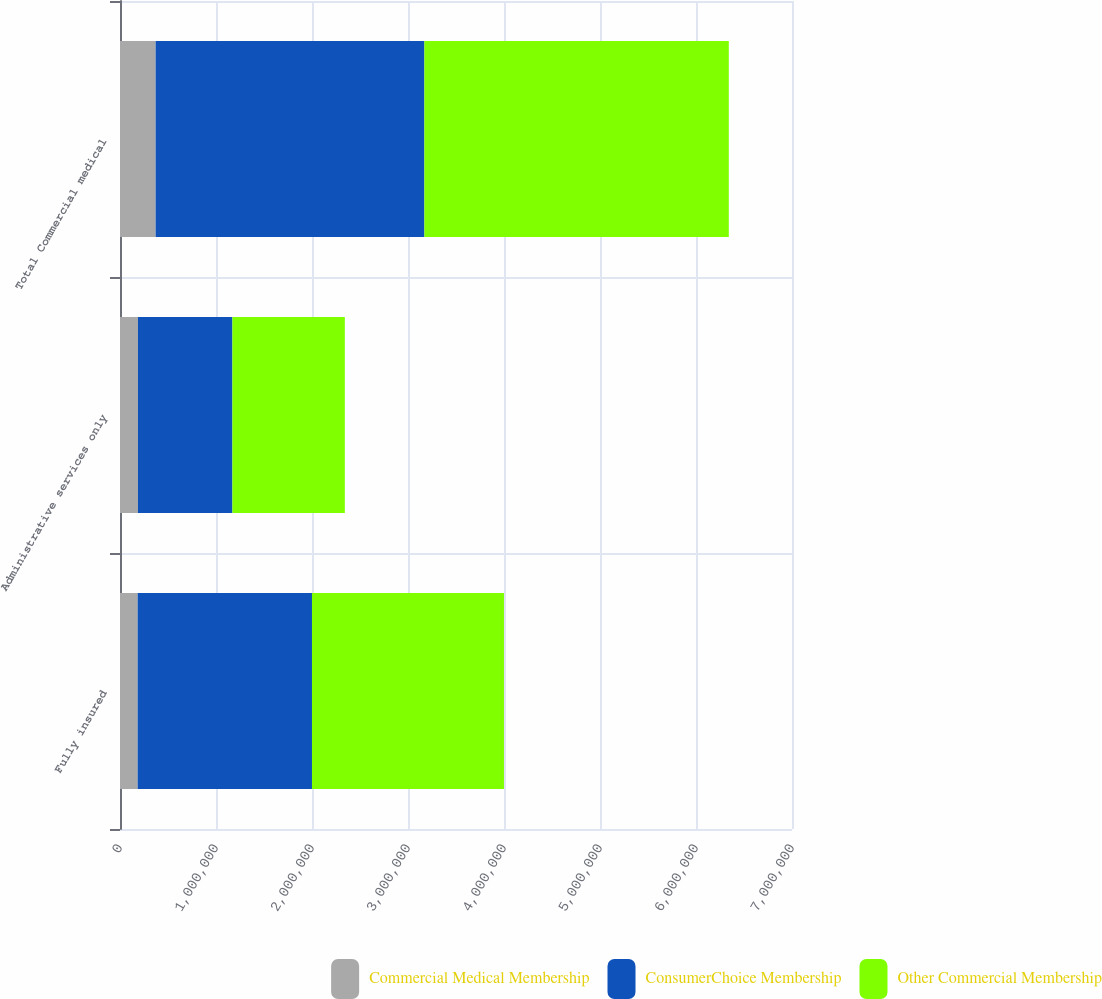Convert chart to OTSL. <chart><loc_0><loc_0><loc_500><loc_500><stacked_bar_chart><ecel><fcel>Fully insured<fcel>Administrative services only<fcel>Total Commercial medical<nl><fcel>Commercial Medical Membership<fcel>184000<fcel>187100<fcel>371100<nl><fcel>ConsumerChoice Membership<fcel>1.8158e+06<fcel>983900<fcel>2.7997e+06<nl><fcel>Other Commercial Membership<fcel>1.9998e+06<fcel>1.171e+06<fcel>3.1708e+06<nl></chart> 